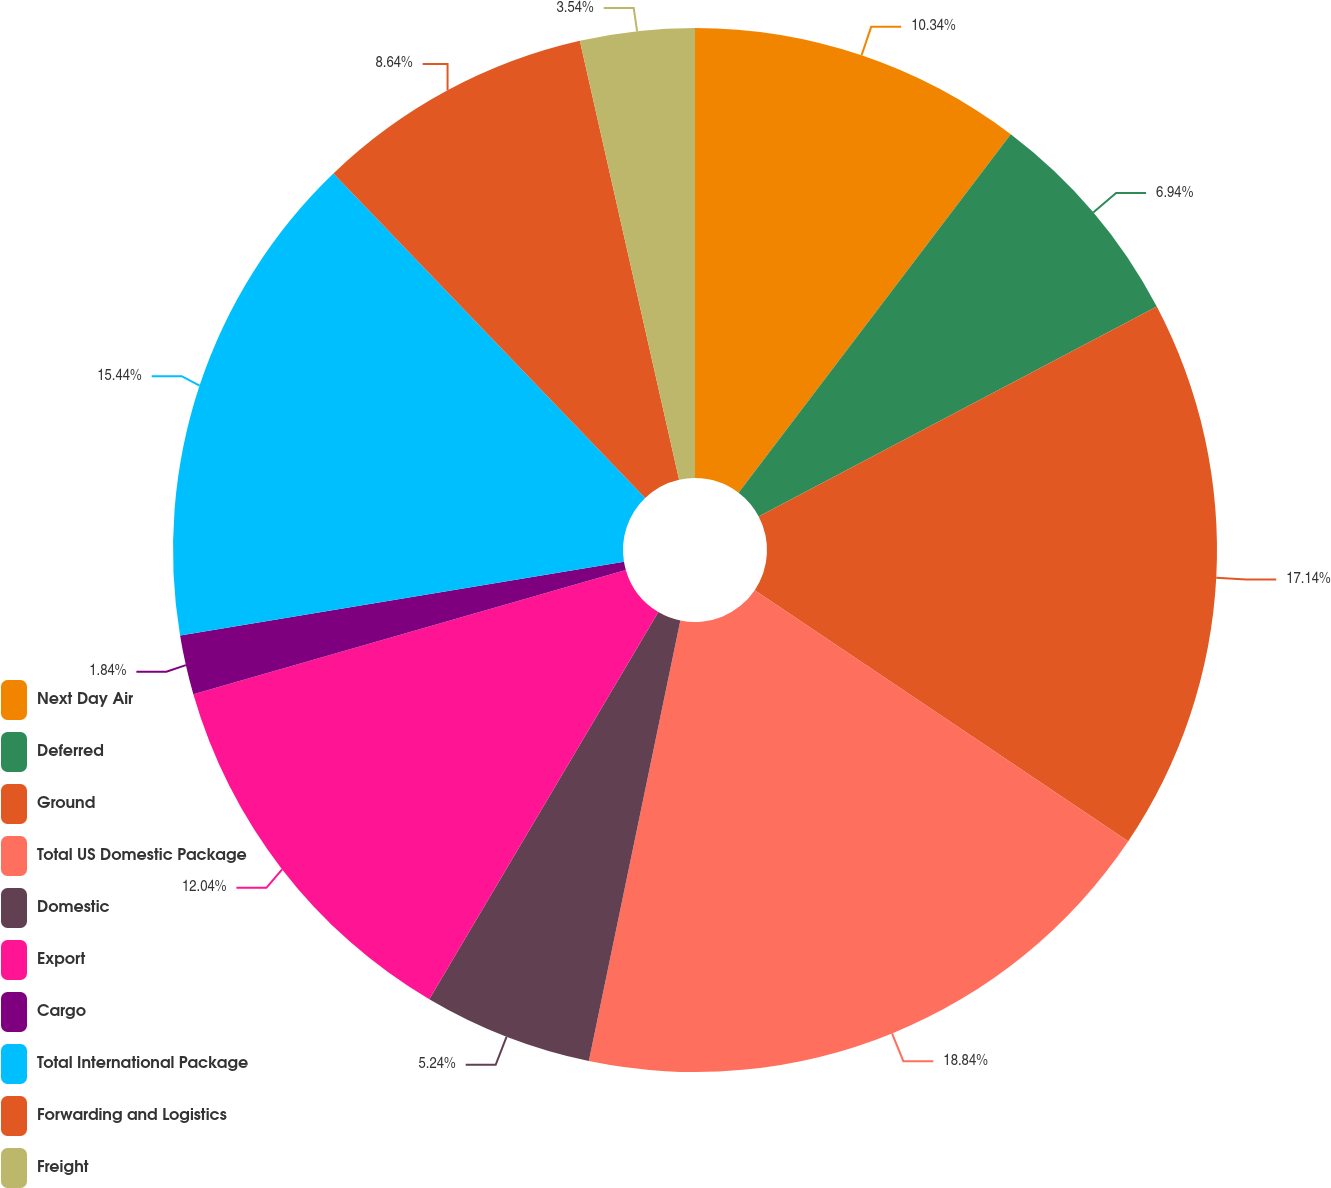Convert chart to OTSL. <chart><loc_0><loc_0><loc_500><loc_500><pie_chart><fcel>Next Day Air<fcel>Deferred<fcel>Ground<fcel>Total US Domestic Package<fcel>Domestic<fcel>Export<fcel>Cargo<fcel>Total International Package<fcel>Forwarding and Logistics<fcel>Freight<nl><fcel>10.34%<fcel>6.94%<fcel>17.14%<fcel>18.84%<fcel>5.24%<fcel>12.04%<fcel>1.84%<fcel>15.44%<fcel>8.64%<fcel>3.54%<nl></chart> 